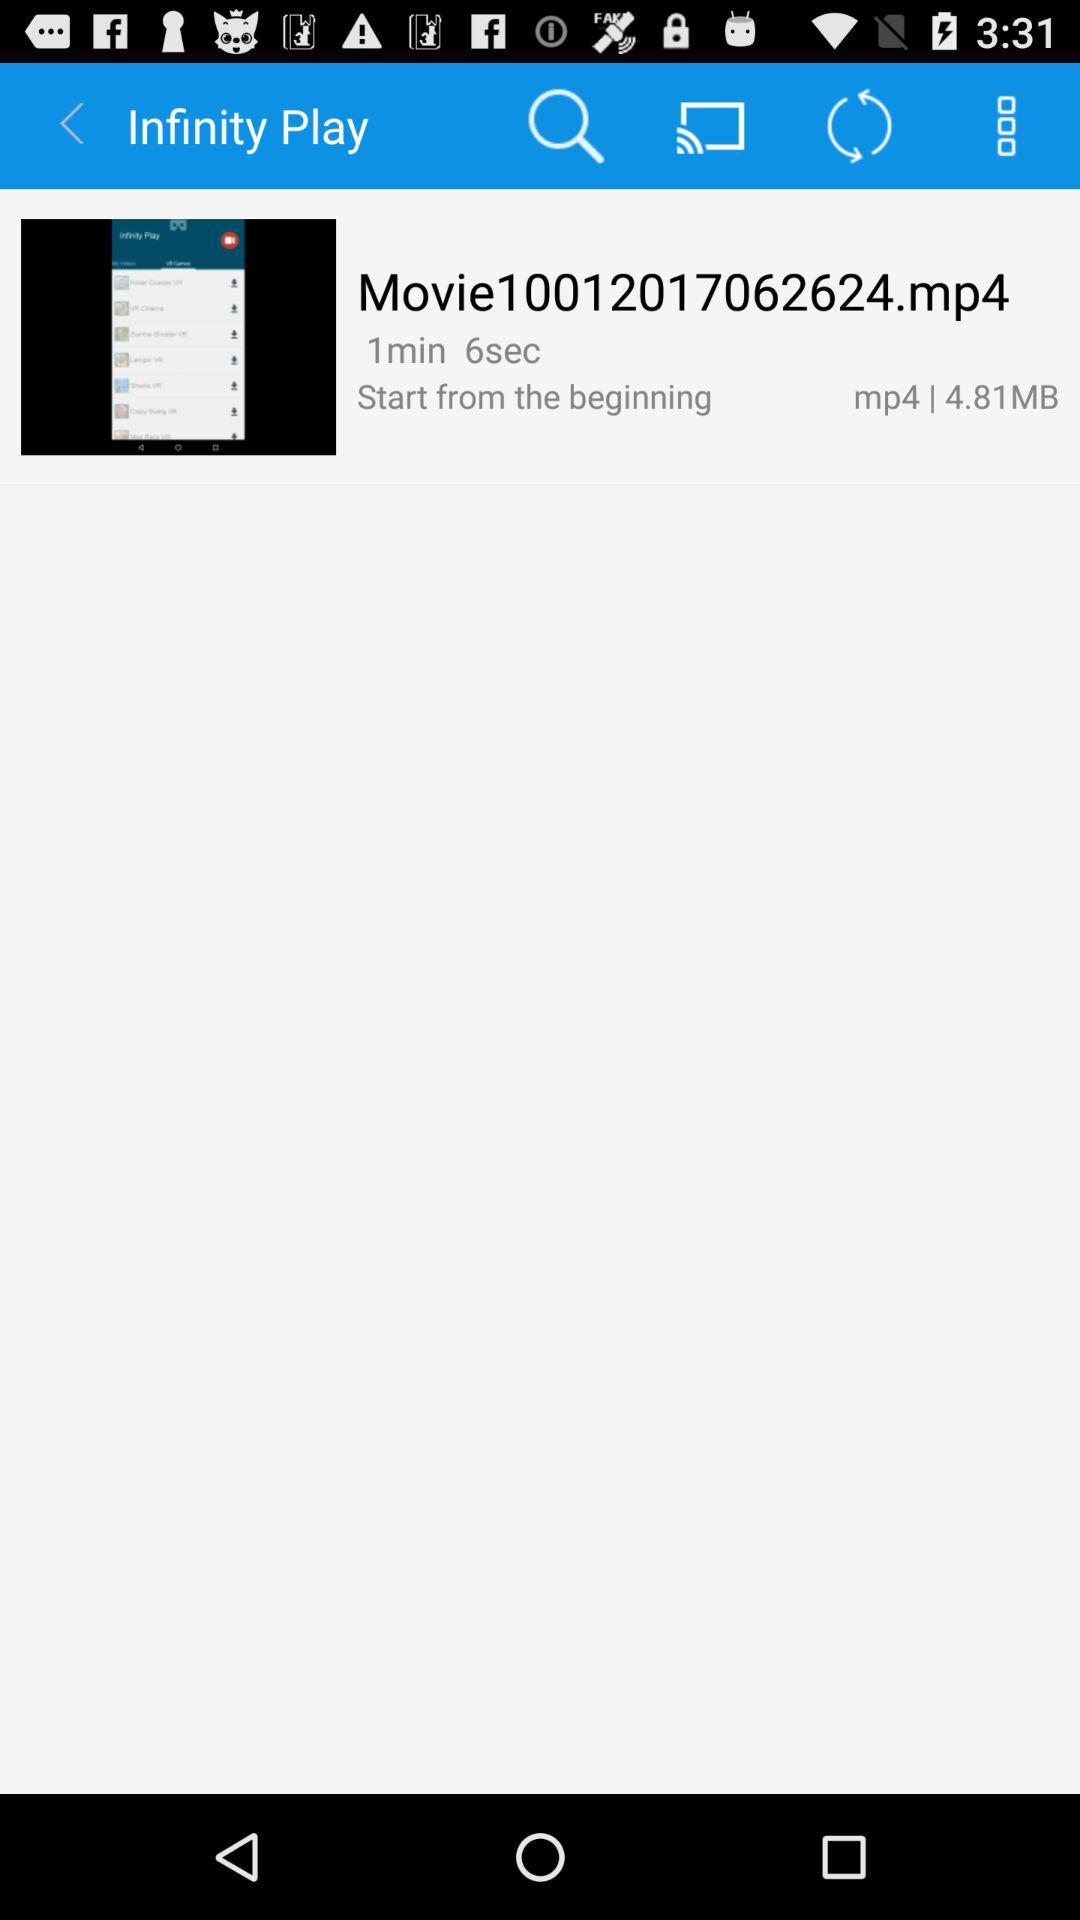How many seconds is the video longer than 1 minute?
Answer the question using a single word or phrase. 6 